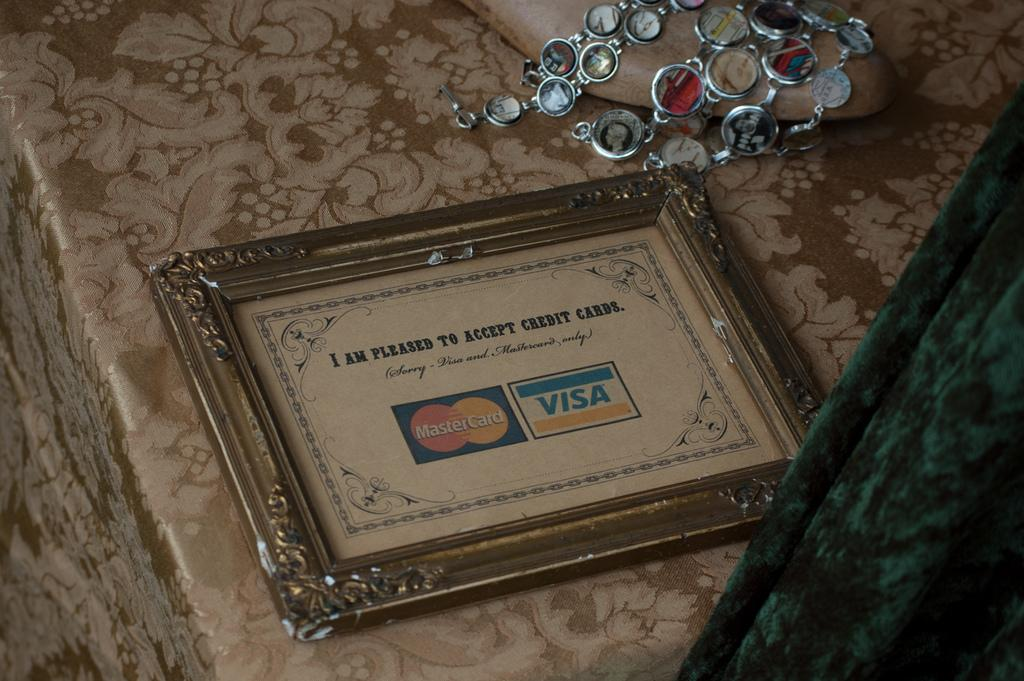<image>
Relay a brief, clear account of the picture shown. A Framed picture that reads "I am pleased to accept credit cards" with the master card and visa logos on the bottom of the text. 